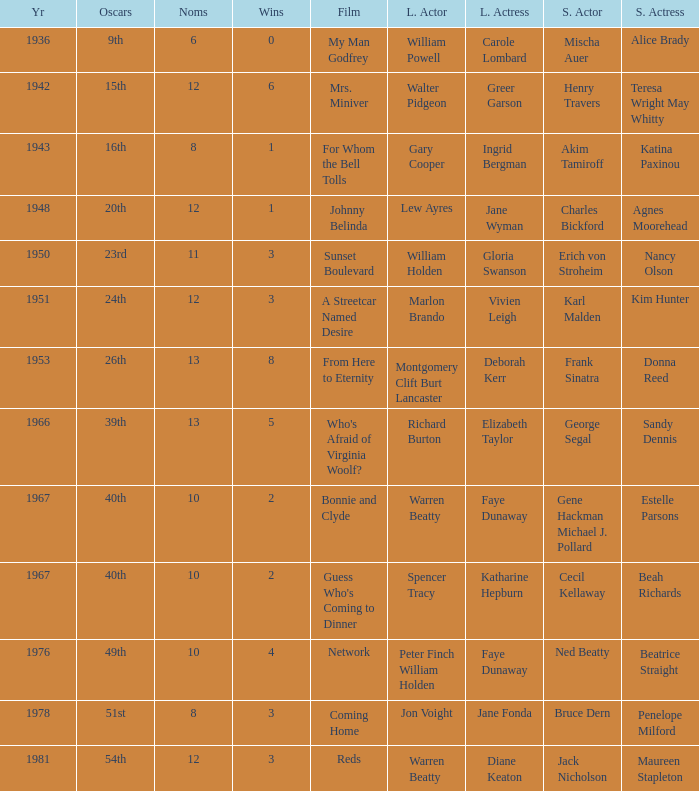Which film had Charles Bickford as supporting actor? Johnny Belinda. 